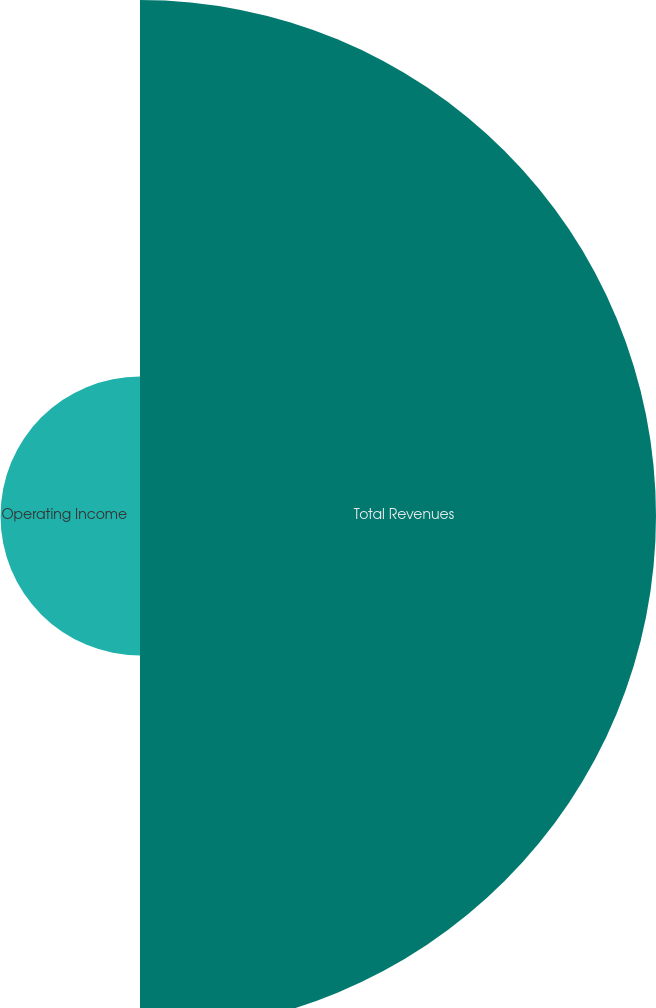<chart> <loc_0><loc_0><loc_500><loc_500><pie_chart><fcel>Total Revenues<fcel>Operating Income<nl><fcel>78.72%<fcel>21.28%<nl></chart> 